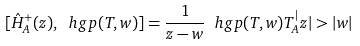<formula> <loc_0><loc_0><loc_500><loc_500>[ \hat { H } _ { A } ^ { + } ( z ) , \ h g p ( T , w ) ] = \frac { 1 } { z - w } \ h g p ( T , w ) T _ { A } ^ { | } z | > | w |</formula> 